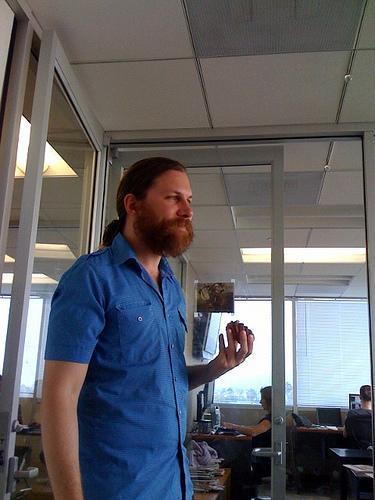How many people are in the background?
Give a very brief answer. 2. How many people are standing?
Give a very brief answer. 1. How many people have ponytails?
Give a very brief answer. 1. How many men are there?
Give a very brief answer. 1. 